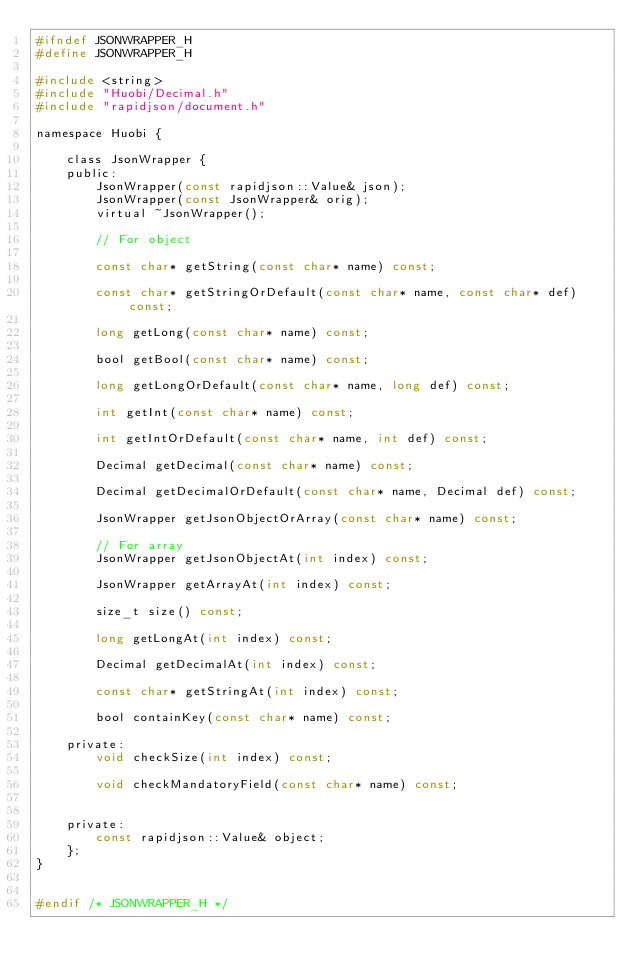Convert code to text. <code><loc_0><loc_0><loc_500><loc_500><_C_>#ifndef JSONWRAPPER_H
#define JSONWRAPPER_H

#include <string>
#include "Huobi/Decimal.h"
#include "rapidjson/document.h"

namespace Huobi {

    class JsonWrapper {
    public:
        JsonWrapper(const rapidjson::Value& json);
        JsonWrapper(const JsonWrapper& orig);
        virtual ~JsonWrapper();

        // For object

        const char* getString(const char* name) const;

        const char* getStringOrDefault(const char* name, const char* def) const;

        long getLong(const char* name) const;

        bool getBool(const char* name) const;

        long getLongOrDefault(const char* name, long def) const;

        int getInt(const char* name) const;
        
        int getIntOrDefault(const char* name, int def) const;
        
        Decimal getDecimal(const char* name) const;
        
        Decimal getDecimalOrDefault(const char* name, Decimal def) const;

        JsonWrapper getJsonObjectOrArray(const char* name) const;

        // For array
        JsonWrapper getJsonObjectAt(int index) const;

        JsonWrapper getArrayAt(int index) const;

        size_t size() const;

        long getLongAt(int index) const;

        Decimal getDecimalAt(int index) const;

        const char* getStringAt(int index) const;

        bool containKey(const char* name) const;

    private:
        void checkSize(int index) const;

        void checkMandatoryField(const char* name) const;


    private:
        const rapidjson::Value& object;
    };
}


#endif /* JSONWRAPPER_H */

</code> 